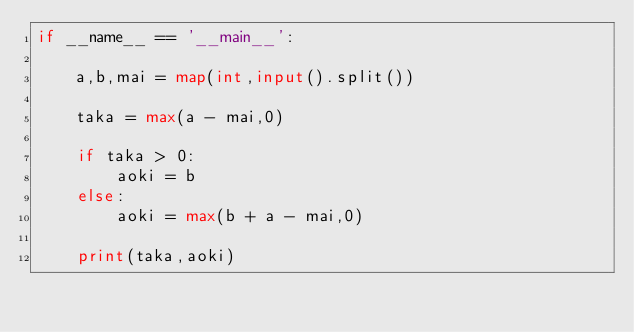<code> <loc_0><loc_0><loc_500><loc_500><_Python_>if __name__ == '__main__':

	a,b,mai = map(int,input().split())

	taka = max(a - mai,0)

	if taka > 0:
		aoki = b
	else:
		aoki = max(b + a - mai,0)

	print(taka,aoki)

</code> 